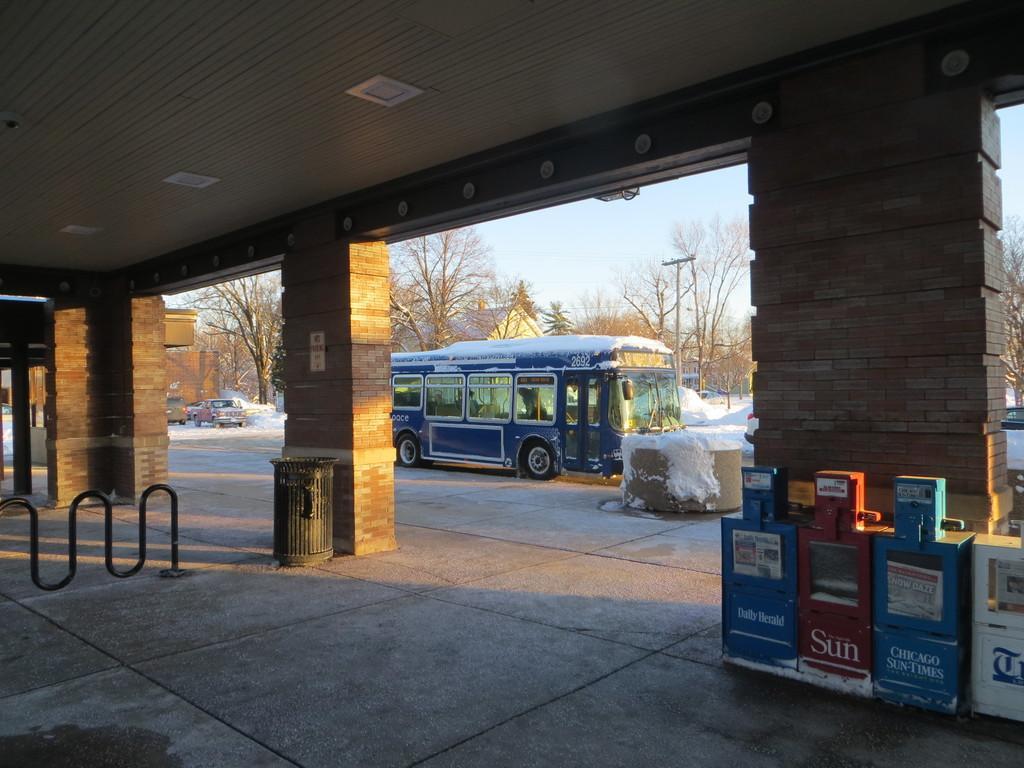Could you give a brief overview of what you see in this image? In this picture we can see few boxes and a dustbin, in the background we can see snow, few vehicles, pole, trees and few buildings. 